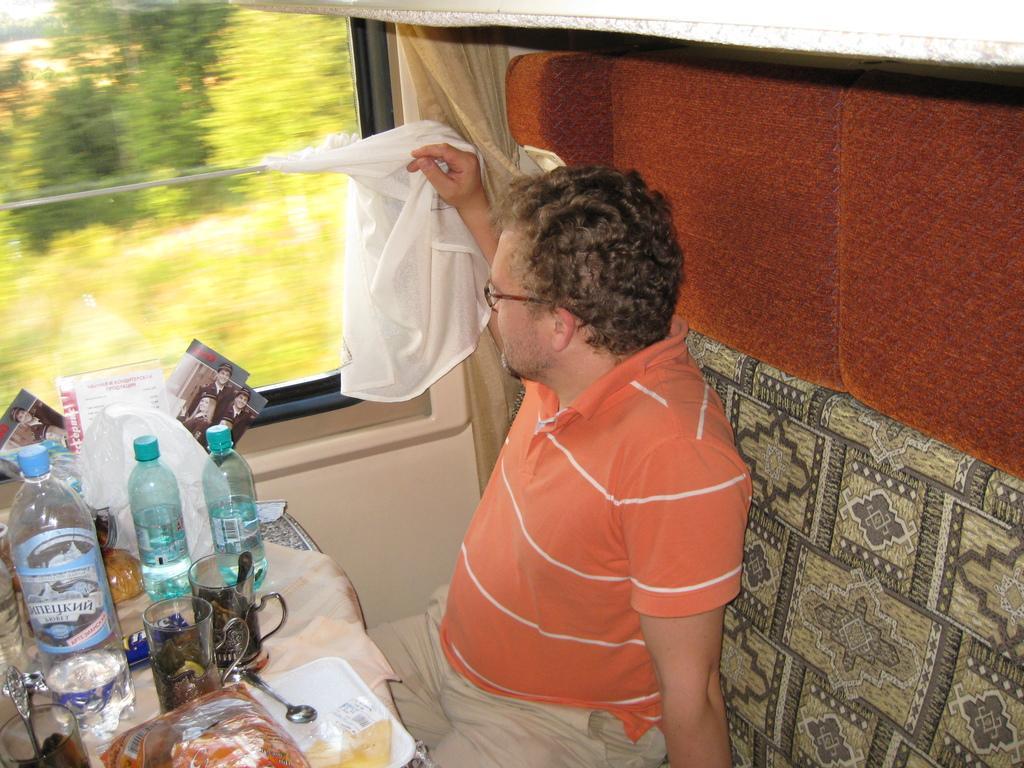Can you describe this image briefly? In this image I can see a man travelling in the train. The person is wearing orange color t-shirt and sitting on the seat. From the window I can see the outside view. There are some trees in green color. In front of this person there is a table. On this table tray, glasses, bottles, spoons books are placed. 